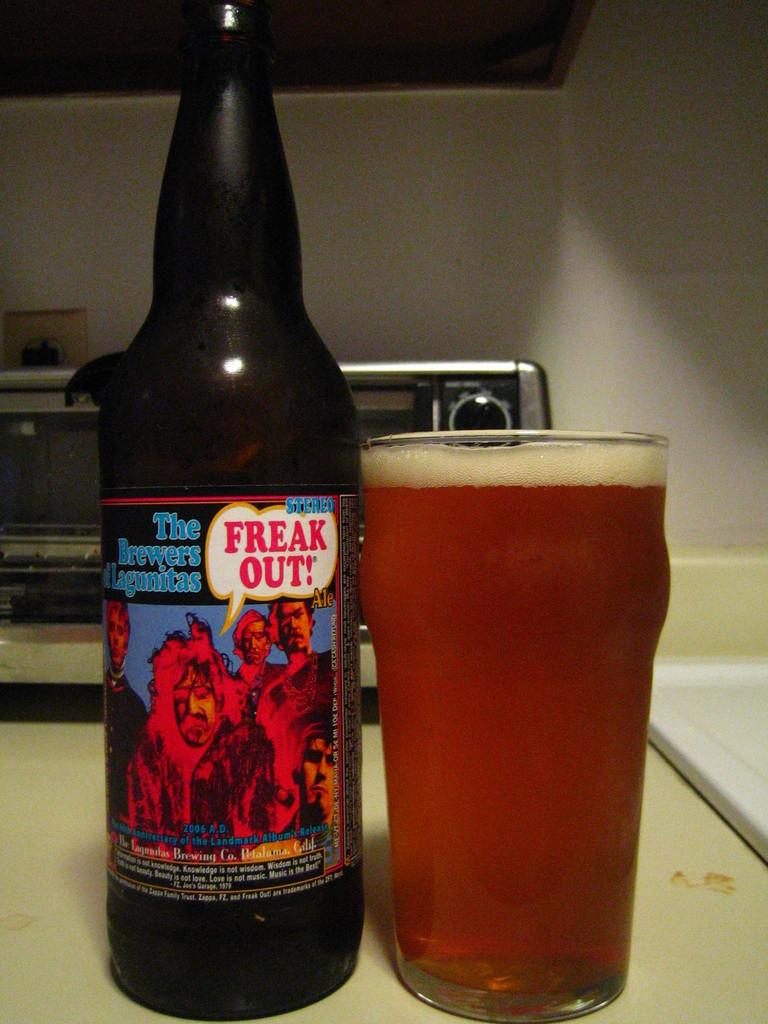<image>
Provide a brief description of the given image. A bottle of beer that says "freak out" on it sits next to a full glass. 